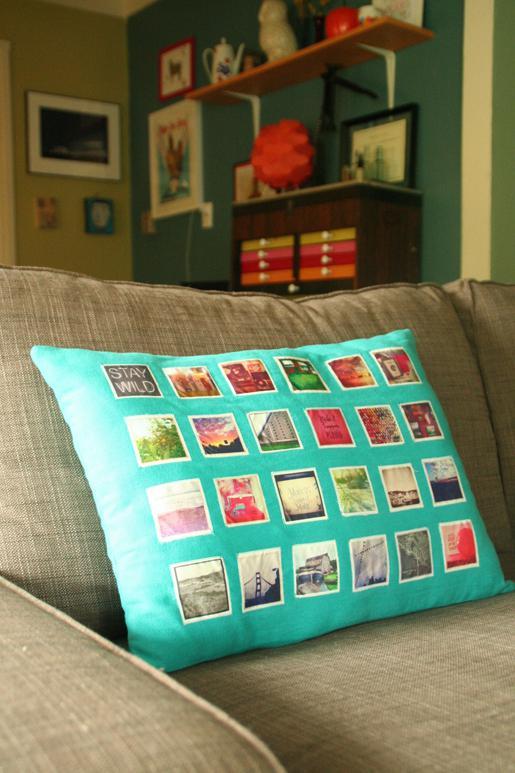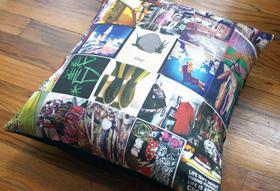The first image is the image on the left, the second image is the image on the right. For the images displayed, is the sentence "At least one of the pillows is designed to look like the Instagram logo." factually correct? Answer yes or no. No. The first image is the image on the left, the second image is the image on the right. Analyze the images presented: Is the assertion "Each image includes a square pillow containing multiple rows of pictures, and in at least one image, the pictures on the pillow form a collage with no space between them." valid? Answer yes or no. Yes. 